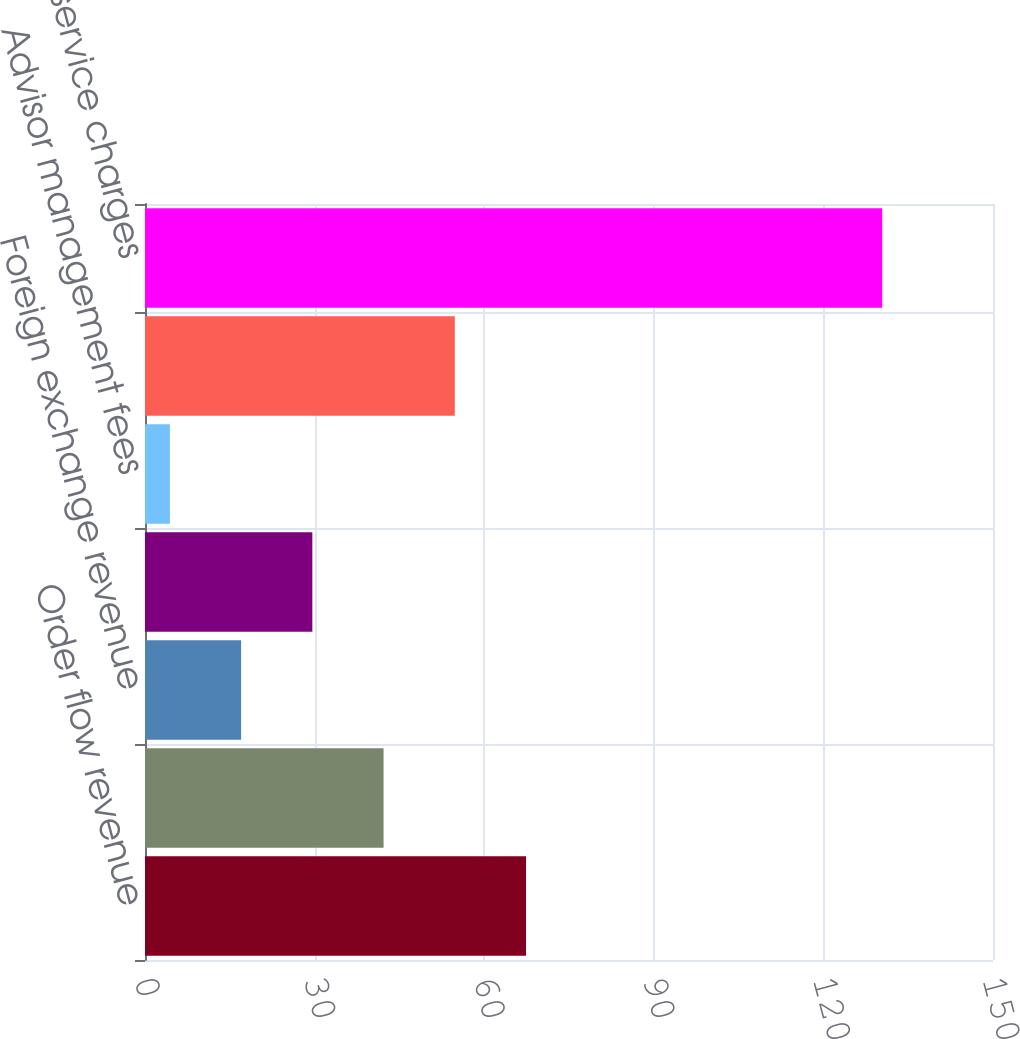Convert chart to OTSL. <chart><loc_0><loc_0><loc_500><loc_500><bar_chart><fcel>Order flow revenue<fcel>Mutual fund service fees<fcel>Foreign exchange revenue<fcel>Reorganization fees<fcel>Advisor management fees<fcel>Other fees and service charges<fcel>Total fees and service charges<nl><fcel>67.4<fcel>42.2<fcel>17<fcel>29.6<fcel>4.4<fcel>54.8<fcel>130.4<nl></chart> 